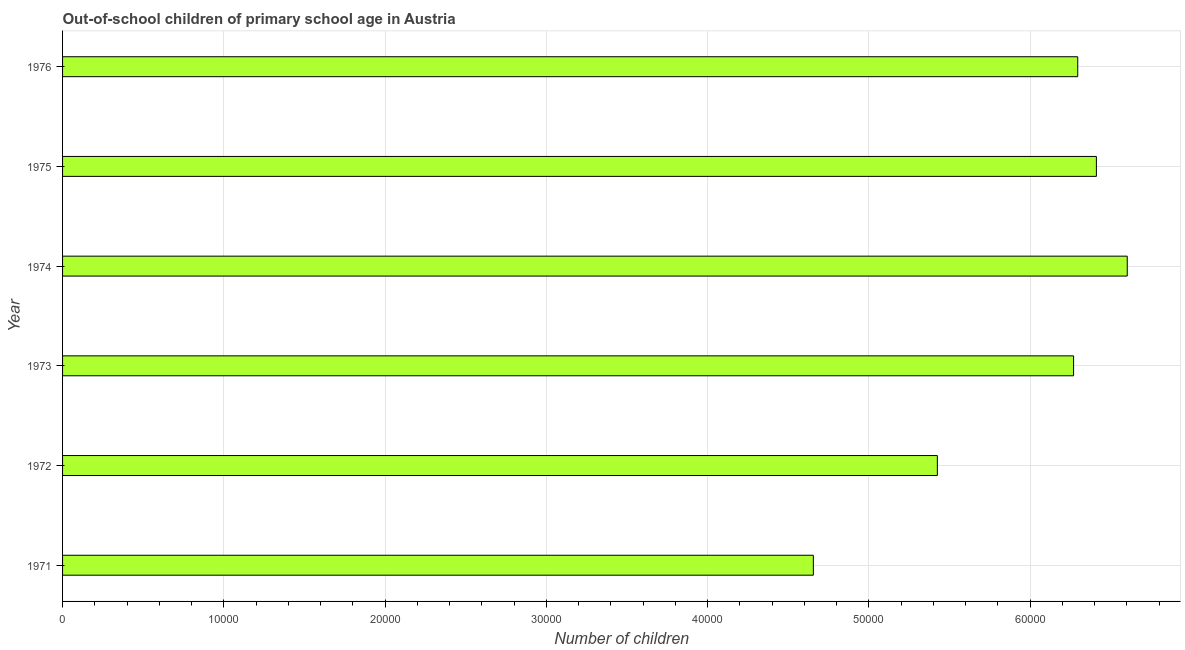Does the graph contain grids?
Your answer should be very brief. Yes. What is the title of the graph?
Offer a terse response. Out-of-school children of primary school age in Austria. What is the label or title of the X-axis?
Keep it short and to the point. Number of children. What is the label or title of the Y-axis?
Keep it short and to the point. Year. What is the number of out-of-school children in 1971?
Make the answer very short. 4.66e+04. Across all years, what is the maximum number of out-of-school children?
Give a very brief answer. 6.60e+04. Across all years, what is the minimum number of out-of-school children?
Offer a terse response. 4.66e+04. In which year was the number of out-of-school children maximum?
Provide a succinct answer. 1974. In which year was the number of out-of-school children minimum?
Offer a terse response. 1971. What is the sum of the number of out-of-school children?
Give a very brief answer. 3.57e+05. What is the difference between the number of out-of-school children in 1971 and 1974?
Provide a short and direct response. -1.95e+04. What is the average number of out-of-school children per year?
Your answer should be compact. 5.94e+04. What is the median number of out-of-school children?
Offer a very short reply. 6.28e+04. Do a majority of the years between 1976 and 1971 (inclusive) have number of out-of-school children greater than 64000 ?
Make the answer very short. Yes. What is the ratio of the number of out-of-school children in 1971 to that in 1975?
Your answer should be very brief. 0.73. Is the difference between the number of out-of-school children in 1971 and 1974 greater than the difference between any two years?
Offer a very short reply. Yes. What is the difference between the highest and the second highest number of out-of-school children?
Give a very brief answer. 1914. Is the sum of the number of out-of-school children in 1973 and 1976 greater than the maximum number of out-of-school children across all years?
Provide a short and direct response. Yes. What is the difference between the highest and the lowest number of out-of-school children?
Your response must be concise. 1.95e+04. In how many years, is the number of out-of-school children greater than the average number of out-of-school children taken over all years?
Your answer should be very brief. 4. How many years are there in the graph?
Ensure brevity in your answer.  6. What is the Number of children of 1971?
Make the answer very short. 4.66e+04. What is the Number of children of 1972?
Your response must be concise. 5.42e+04. What is the Number of children in 1973?
Your answer should be compact. 6.27e+04. What is the Number of children in 1974?
Your answer should be very brief. 6.60e+04. What is the Number of children in 1975?
Give a very brief answer. 6.41e+04. What is the Number of children of 1976?
Ensure brevity in your answer.  6.30e+04. What is the difference between the Number of children in 1971 and 1972?
Ensure brevity in your answer.  -7690. What is the difference between the Number of children in 1971 and 1973?
Your answer should be compact. -1.61e+04. What is the difference between the Number of children in 1971 and 1974?
Your answer should be very brief. -1.95e+04. What is the difference between the Number of children in 1971 and 1975?
Ensure brevity in your answer.  -1.76e+04. What is the difference between the Number of children in 1971 and 1976?
Provide a short and direct response. -1.64e+04. What is the difference between the Number of children in 1972 and 1973?
Give a very brief answer. -8447. What is the difference between the Number of children in 1972 and 1974?
Your answer should be compact. -1.18e+04. What is the difference between the Number of children in 1972 and 1975?
Keep it short and to the point. -9862. What is the difference between the Number of children in 1972 and 1976?
Provide a short and direct response. -8705. What is the difference between the Number of children in 1973 and 1974?
Offer a terse response. -3329. What is the difference between the Number of children in 1973 and 1975?
Give a very brief answer. -1415. What is the difference between the Number of children in 1973 and 1976?
Your answer should be very brief. -258. What is the difference between the Number of children in 1974 and 1975?
Your answer should be very brief. 1914. What is the difference between the Number of children in 1974 and 1976?
Offer a terse response. 3071. What is the difference between the Number of children in 1975 and 1976?
Give a very brief answer. 1157. What is the ratio of the Number of children in 1971 to that in 1972?
Make the answer very short. 0.86. What is the ratio of the Number of children in 1971 to that in 1973?
Give a very brief answer. 0.74. What is the ratio of the Number of children in 1971 to that in 1974?
Give a very brief answer. 0.7. What is the ratio of the Number of children in 1971 to that in 1975?
Your answer should be compact. 0.73. What is the ratio of the Number of children in 1971 to that in 1976?
Keep it short and to the point. 0.74. What is the ratio of the Number of children in 1972 to that in 1973?
Your answer should be very brief. 0.86. What is the ratio of the Number of children in 1972 to that in 1974?
Your response must be concise. 0.82. What is the ratio of the Number of children in 1972 to that in 1975?
Keep it short and to the point. 0.85. What is the ratio of the Number of children in 1972 to that in 1976?
Provide a succinct answer. 0.86. What is the ratio of the Number of children in 1973 to that in 1974?
Ensure brevity in your answer.  0.95. What is the ratio of the Number of children in 1973 to that in 1975?
Keep it short and to the point. 0.98. What is the ratio of the Number of children in 1973 to that in 1976?
Ensure brevity in your answer.  1. What is the ratio of the Number of children in 1974 to that in 1976?
Your answer should be compact. 1.05. What is the ratio of the Number of children in 1975 to that in 1976?
Provide a short and direct response. 1.02. 